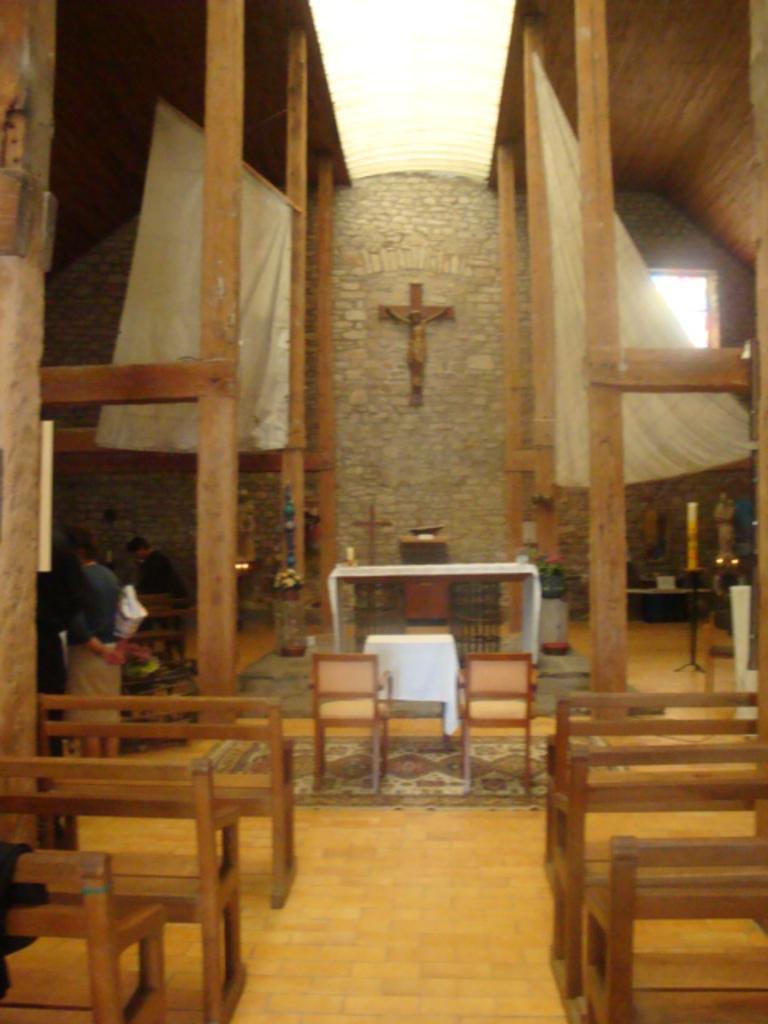In one or two sentences, can you explain what this image depicts? In this picture we can see benches, chairs on the floor, table with a white cloth on it and in the background we can see a cross on the wall, curtains, window, statues, candle stand, wooden pillars and some objects and some people. 